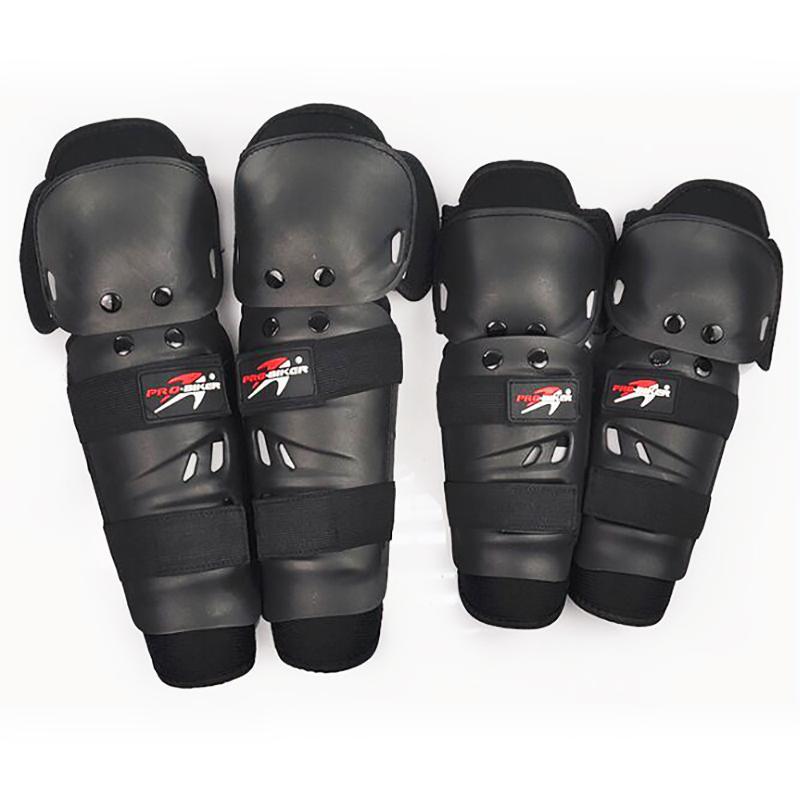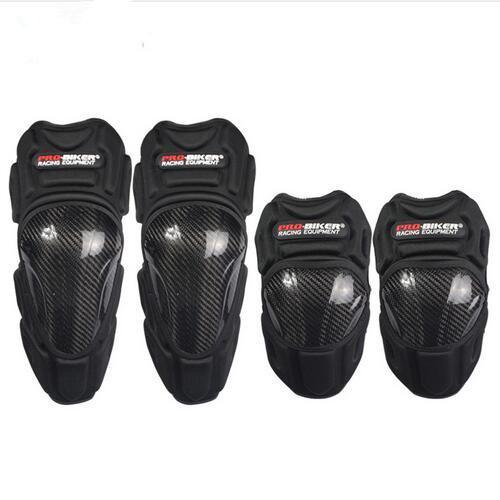The first image is the image on the left, the second image is the image on the right. Considering the images on both sides, is "One image contains just one pair of black knee pads." valid? Answer yes or no. No. The first image is the image on the left, the second image is the image on the right. For the images shown, is this caption "Exactly eight pieces of equipment are shown in groups of four each." true? Answer yes or no. Yes. 